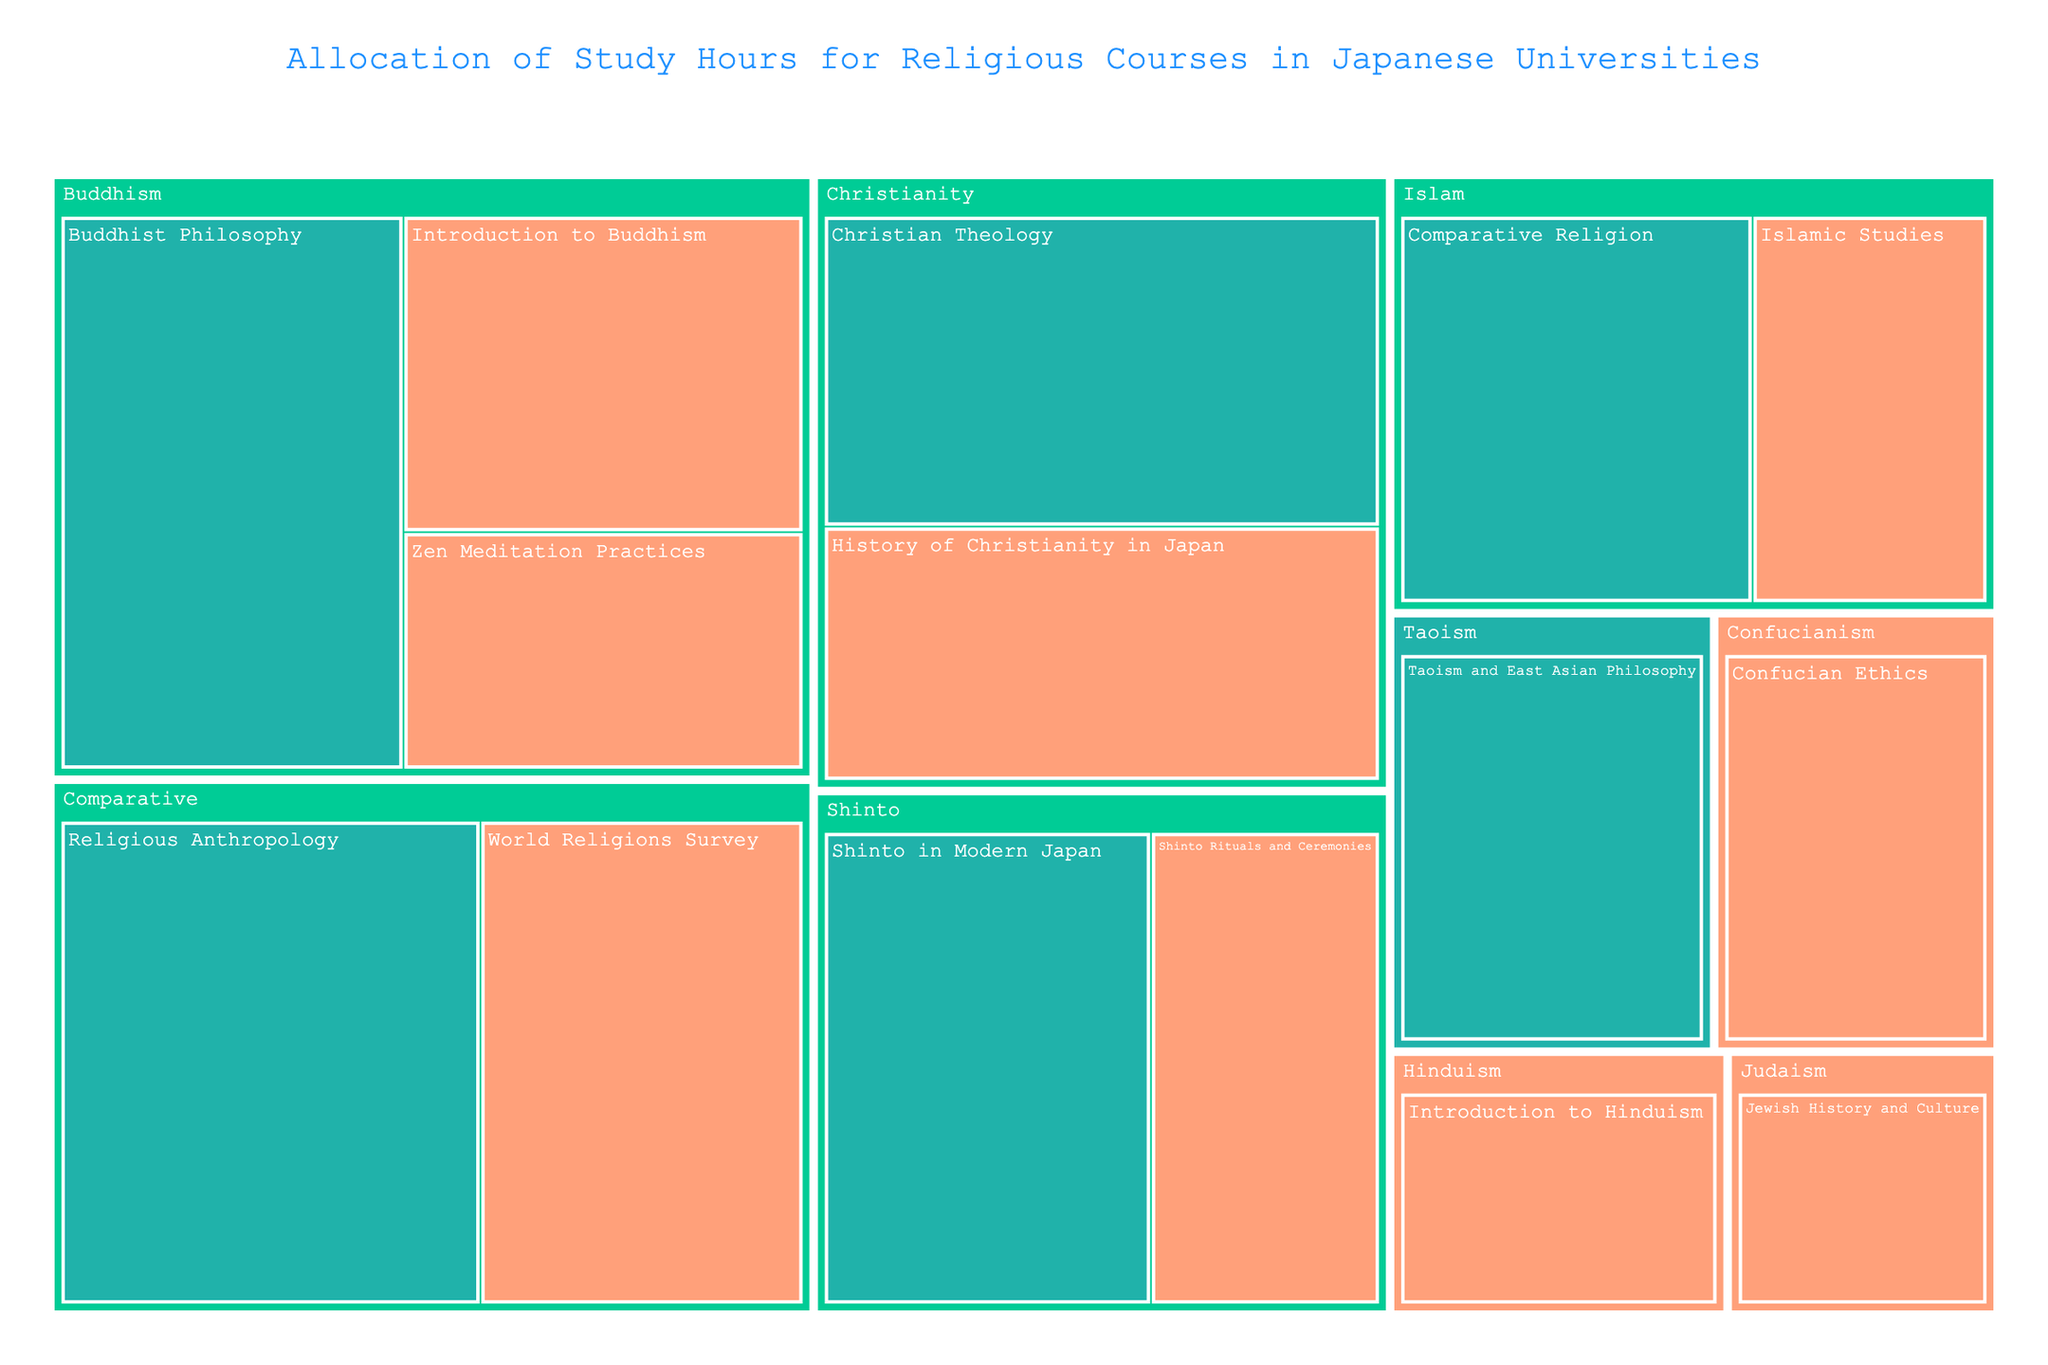What's the title of the treemap? The title is typically found at the top of the figure, which helps describe what the figure is about.
Answer: Allocation of Study Hours for Religious Courses in Japanese Universities Which course has the highest number of study hours? By looking at the size of the rectangles in the treemap, the largest rectangle corresponds to the highest number of study hours.
Answer: Religious Anthropology Which religion has the most courses in the treemap? Count the number of different courses listed under each religion label.
Answer: Buddhism What's the total study hours allocated to Christian courses? Sum the study hours for all courses under Christianity: History of Christianity in Japan (45 hours) and Christian Theology (55 hours). 45 + 55 = 100
Answer: 100 Which academic level accounts for more study hours in Buddhism courses? Compare the sum of study hours for Undergraduate vs. Graduate Buddhism courses. Undergraduate: 40 + 30 = 70, Graduate: 60. Undergraduate has more hours.
Answer: Undergraduate How many study hours are allocated to Shinto courses at the Graduate level? Find the rectangle labeled under Shinto and Graduate, then sum the hours for those courses. Shinto in Modern Japan (50 hours).
Answer: 50 Which religion has the least study hours at the Undergraduate level? Identify the smallest rectangle among the Undergraduate-level courses across different religions. Jewish History and Culture under Judaism (20 hours).
Answer: Judaism Compare the total study hours of Comparative courses with Christianity courses. Which one has more? Sum the study hours for Comparative courses: World Religions Survey (50 hours) + Religious Anthropology (65 hours) = 115. Christianity: 100 hours. Comparative has more.
Answer: Comparative Which Undergraduate course has the largest study hours? Identify the largest rectangle among Undergraduate courses. World Religions Survey (50 hours).
Answer: World Religions Survey 